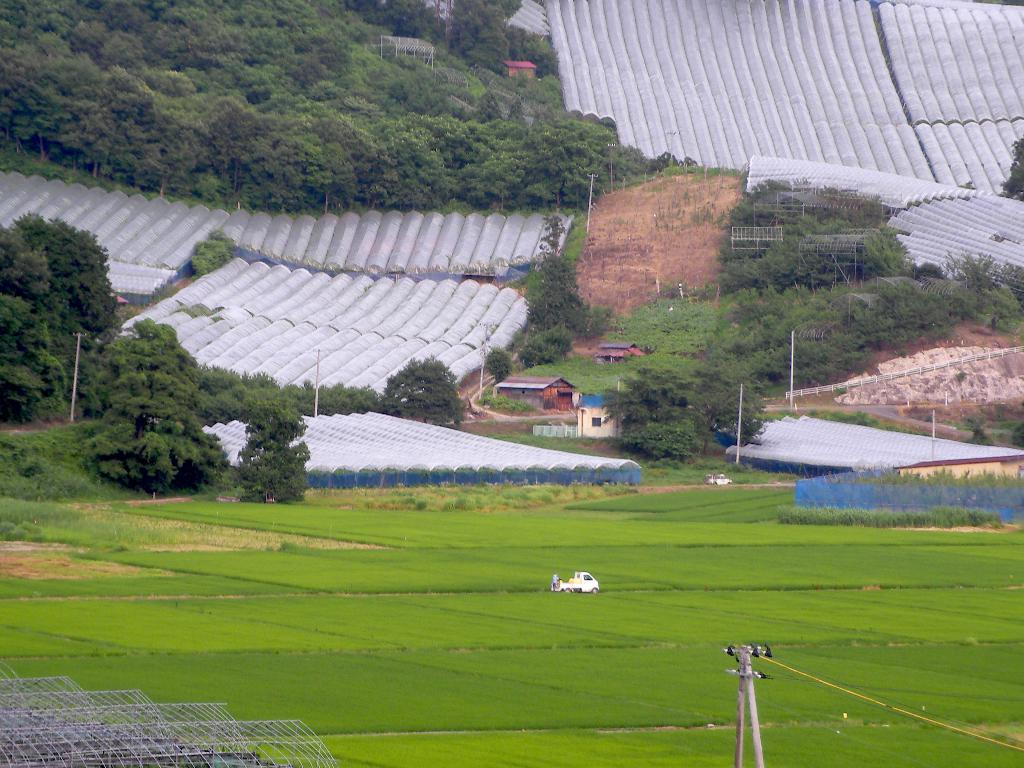What type of vegetation can be seen in the image? There are trees in the image. What type of structures are present in the image? There are houses and shelters for nursery in the image. What vehicle can be seen in the image? There is a mini truck in the image. What is the ground covered with in the image? Grass is present on the ground in the image. How many islands can be seen in the image? There are no islands present in the image. What type of furniture is visible in the image? There is no furniture visible in the image. 